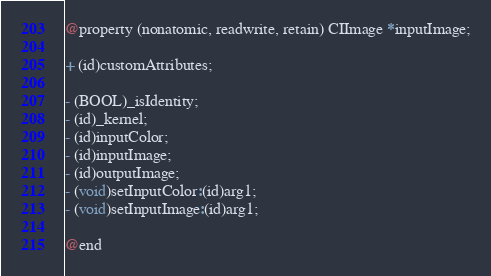Convert code to text. <code><loc_0><loc_0><loc_500><loc_500><_C_>@property (nonatomic, readwrite, retain) CIImage *inputImage;

+ (id)customAttributes;

- (BOOL)_isIdentity;
- (id)_kernel;
- (id)inputColor;
- (id)inputImage;
- (id)outputImage;
- (void)setInputColor:(id)arg1;
- (void)setInputImage:(id)arg1;

@end
</code> 